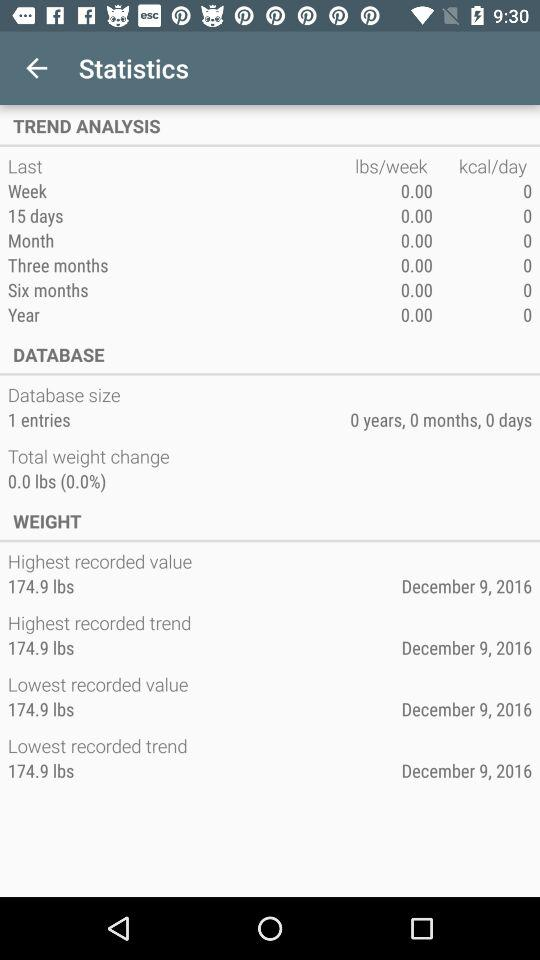What is the difference between the highest recorded weight value and the lowest recorded weight value?
Answer the question using a single word or phrase. 0.0 lbs 